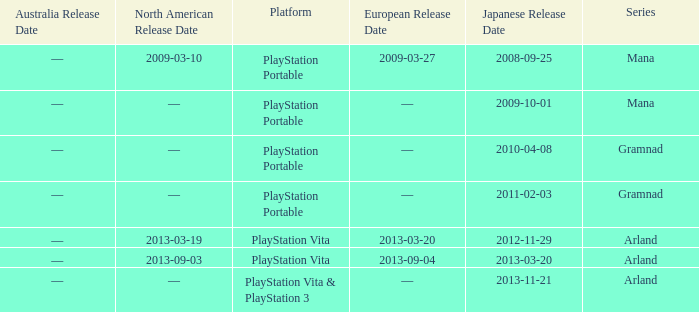What is the series with a North American release date on 2013-09-03? Arland. 